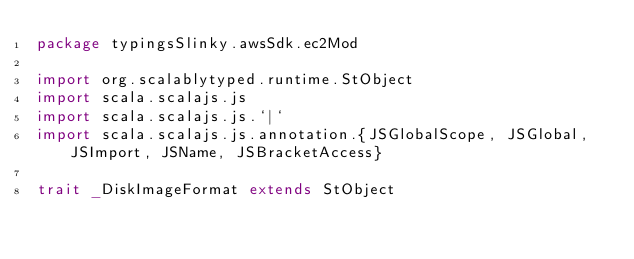<code> <loc_0><loc_0><loc_500><loc_500><_Scala_>package typingsSlinky.awsSdk.ec2Mod

import org.scalablytyped.runtime.StObject
import scala.scalajs.js
import scala.scalajs.js.`|`
import scala.scalajs.js.annotation.{JSGlobalScope, JSGlobal, JSImport, JSName, JSBracketAccess}

trait _DiskImageFormat extends StObject
</code> 